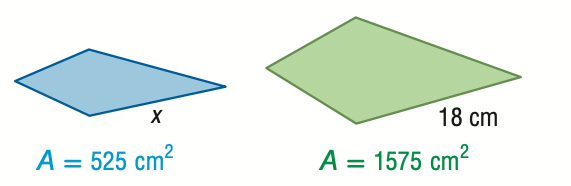Answer the mathemtical geometry problem and directly provide the correct option letter.
Question: For the pair of similar figures, use the given areas to find x.
Choices: A: 6.0 B: 10.4 C: 31.2 D: 54.0 B 